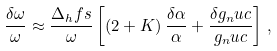Convert formula to latex. <formula><loc_0><loc_0><loc_500><loc_500>\frac { \delta \omega } { \omega } \approx \frac { \Delta _ { h } f s } { \omega } \left [ \left ( 2 + K \right ) \frac { \delta \alpha } { \alpha } + \frac { \delta g _ { n } u c } { g _ { n } u c } \right ] \, ,</formula> 